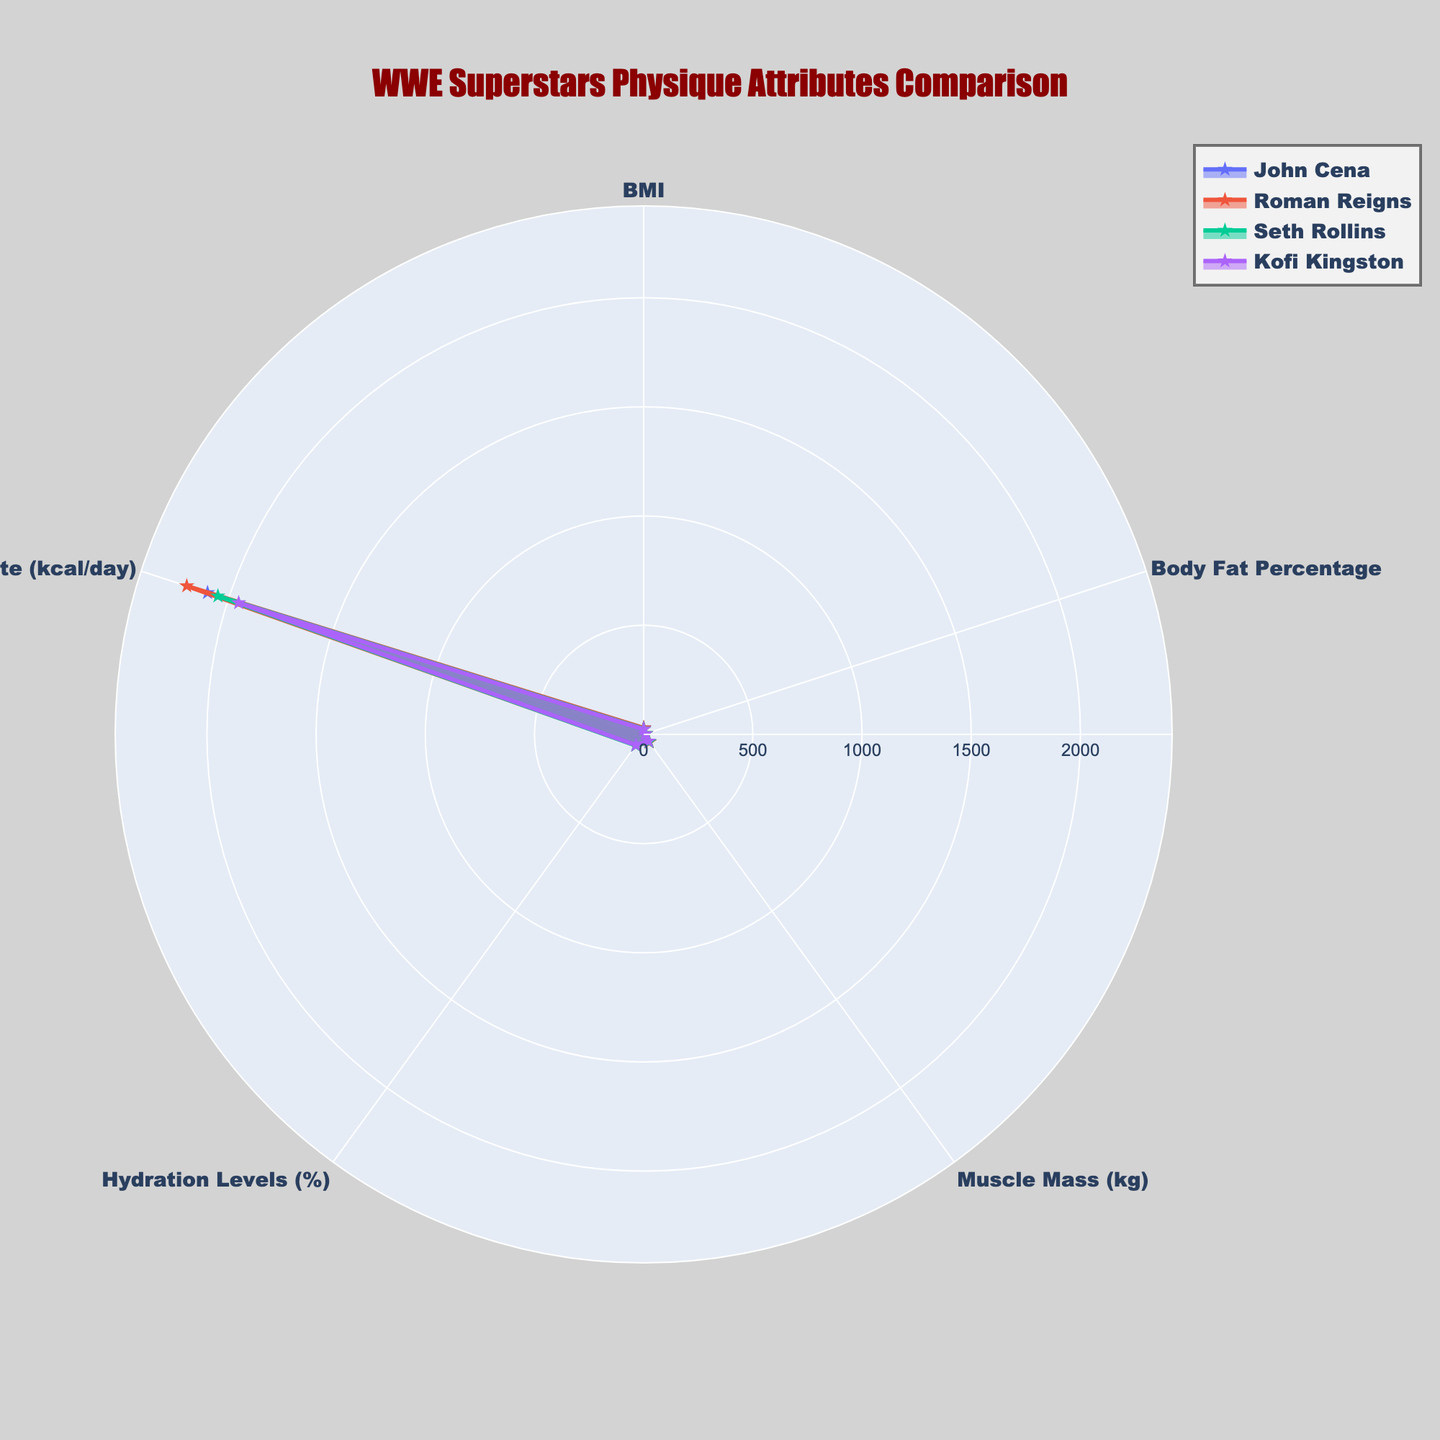What's the title of the radar chart? The title of the plot is written visibly at the top of the figure.
Answer: WWE Superstars Physique Attributes Comparison How many attributes are being compared in the radar chart? Each attribute used to create the radar chart corresponds to one of the axes radiating out from the center. Count these axes.
Answer: Five Between John Cena and Seth Rollins, who has a higher Body Fat Percentage? Check the radial axis for Body Fat Percentage and compare the points for John Cena and Seth Rollins.
Answer: Seth Rollins Which wrestler has the highest Basal Metabolic Rate? Look for the point on the Basal Metabolic Rate axis that is farthest from the center.
Answer: Roman Reigns Compare the Muscle Mass values for the wrestlers. Who has the lowest value? Look for the least extended value on the Muscle Mass axis.
Answer: Kofi Kingston Is Seth Rollins' Hydration Levels higher than John Cena's? Compare the points for Hydration Levels corresponding to Seth Rollins and John Cena.
Answer: Yes What is the range of the radial axis in the polar layout? The entirety of the radial axis is visible and denotes the range.
Answer: 0 to approximately 48.5 Calculate the average BMI of all the wrestlers. Sum all the BMI values and divide by the number of wrestlers: (28.6 + 29.2 + 24.9 + 23.5) / 4.
Answer: 26.55 Which two wrestlers have the closest values in Body Fat Percentage? Compare the values for each wrestler in Body Fat Percentage and find the smallest difference.
Answer: John Cena and Kofi Kingston Does Kofi Kingston have higher or lower Muscle Mass than John Cena? Compare the points for Muscle Mass for Kofi Kingston and John Cena.
Answer: Lower 